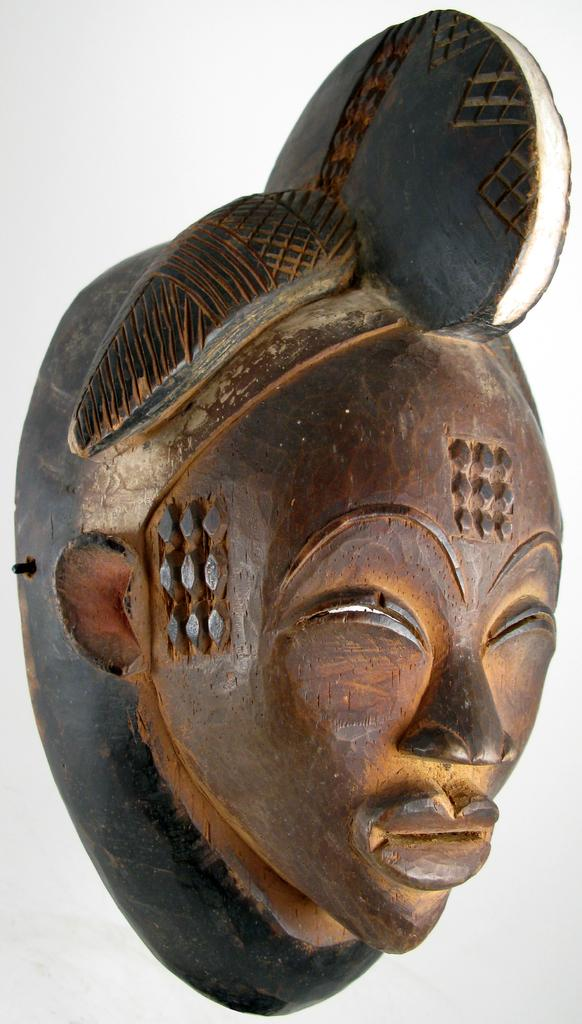What is the main subject in the foreground of the image? There is a mannequin in the foreground of the image. What material is the mannequin made of? The mannequin is made up of wood. How many hands does the mannequin have in the image? The mannequin does not have hands, as it is made of wood and is not a human figure. 